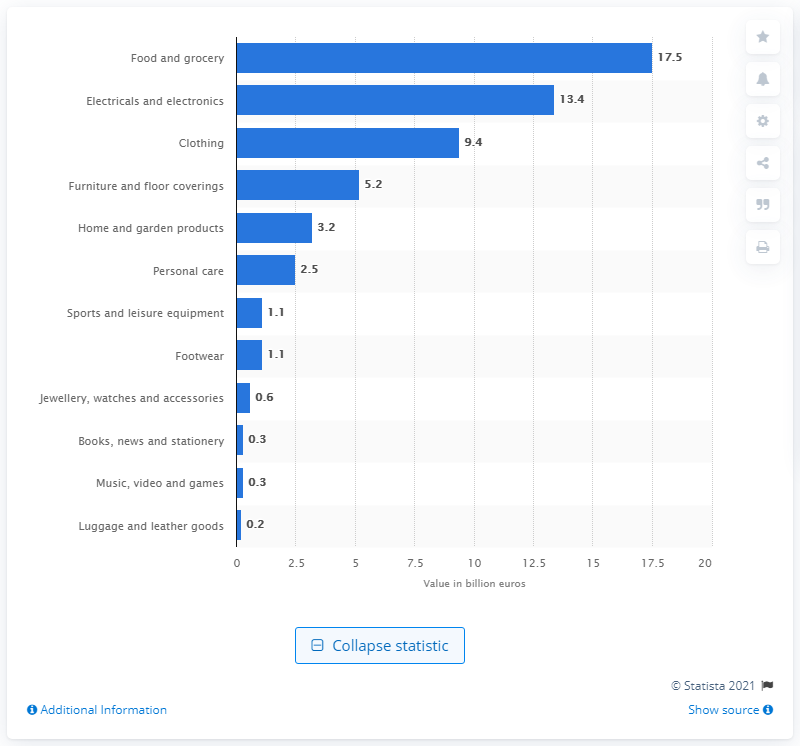Give some essential details in this illustration. The electrical and electronics sector in Germany is expected to experience significant growth, with a forecast of 13.4% over the next year. The food and grocery sector is forecasted to grow by between 2013 and 2018, with an estimated value of 17.5%. 